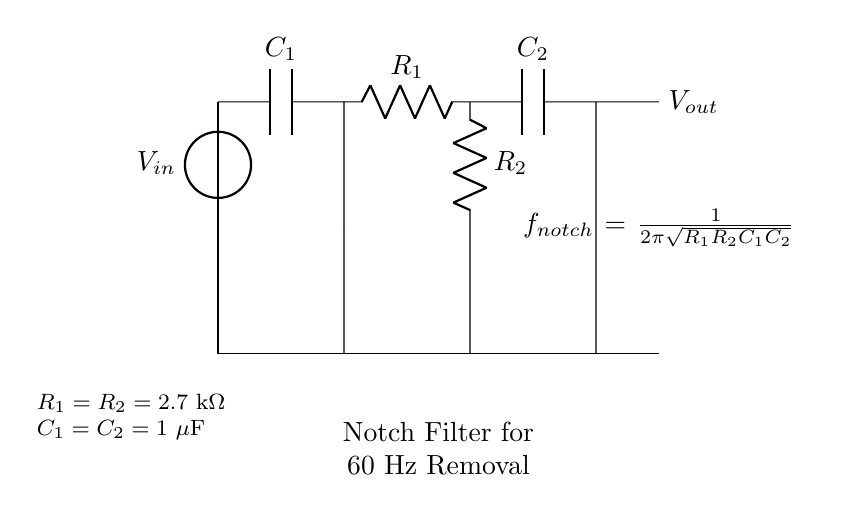What type of filter is this circuit? The circuit is designed as a notch filter. A notch filter is specifically intended to attenuate a specific frequency while allowing others to pass. This is noted in the annotation.
Answer: Notch filter What is the notch frequency of this filter? The notch frequency is determined using the formula provided, which is \( \frac{1}{2\pi\sqrt{R_1R_2C_1C_2}} \). Given the values \( R_1 = R_2 = 2.7 \text{ k}\Omega \) and \( C_1 = C_2 = 1 \text{ }\mu\text{F} \), can be calculated to find the specific frequency at which the filter operates.
Answer: 59.46 Hz What components make up the high-pass filter section? The high-pass filter is comprised of a capacitor \( C_1 \) and a resistor \( R_1 \). The capacitor blocks low frequencies while the resistor helps control the filter's response.
Answer: Capacitor and resistor Where is the output voltage taken from in this circuit? The output voltage \( V_{out} \) is taken from the connection after the low-pass filter section, specifically from the second capacitor \( C_2 \). This means the output reflects the filtered signals beyond the notch frequency.
Answer: After C2 What is the role of resistor \( R_2 \) in this circuit? Resistor \( R_2 \) forms part of the low-pass filter with capacitor \( C_2 \), determining the cutoff frequency for higher frequencies, allowing signals below that frequency to pass through while attenuating higher frequencies.
Answer: Attenuate higher frequencies What is the effect of increasing the capacitance \( C_1 \)? Increasing capacitance \( C_1 \) effectively lowers the cutoff frequency of the high-pass filter section, allowing less high-frequency signal to pass and increasing the attenuation at the notch frequency, altering the filter's performance accordingly.
Answer: Lowers the high-pass cutoff frequency What happens if the resistor values \( R_1 \) and \( R_2 \) are decreased? Decreasing the resistor values \( R_1 \) and \( R_2 \) will increase the bandwidth of frequencies allowed through the notch filter, making it less selective, since it changes the calculated notch frequency to be higher.
Answer: Increases bandwidth 